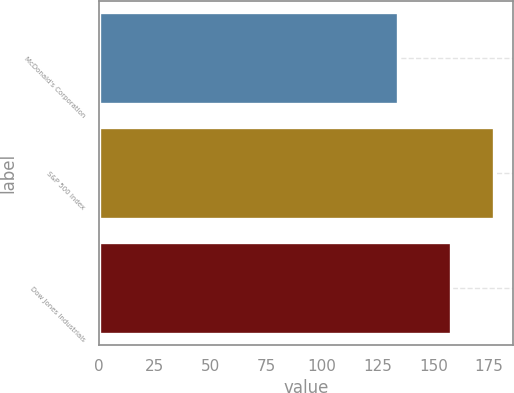Convert chart. <chart><loc_0><loc_0><loc_500><loc_500><bar_chart><fcel>McDonald's Corporation<fcel>S&P 500 Index<fcel>Dow Jones Industrials<nl><fcel>134<fcel>177<fcel>158<nl></chart> 